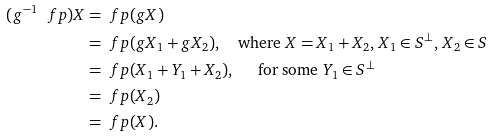<formula> <loc_0><loc_0><loc_500><loc_500>( g ^ { - 1 } \ f p ) X & = \ f p ( g X ) \\ & = \ f p ( g X _ { 1 } + g X _ { 2 } ) , \quad \text {where $X=X_{1}+X_{2}$, $X_{1}\in S^{\bot}$, $X_{2}\in S$} \\ & = \ f p ( X _ { 1 } + Y _ { 1 } + X _ { 2 } ) , \, \quad \text { for some $Y_{1}\in S^{\bot}$} \\ & = \ f p ( X _ { 2 } ) \\ & = \ f p ( X ) .</formula> 